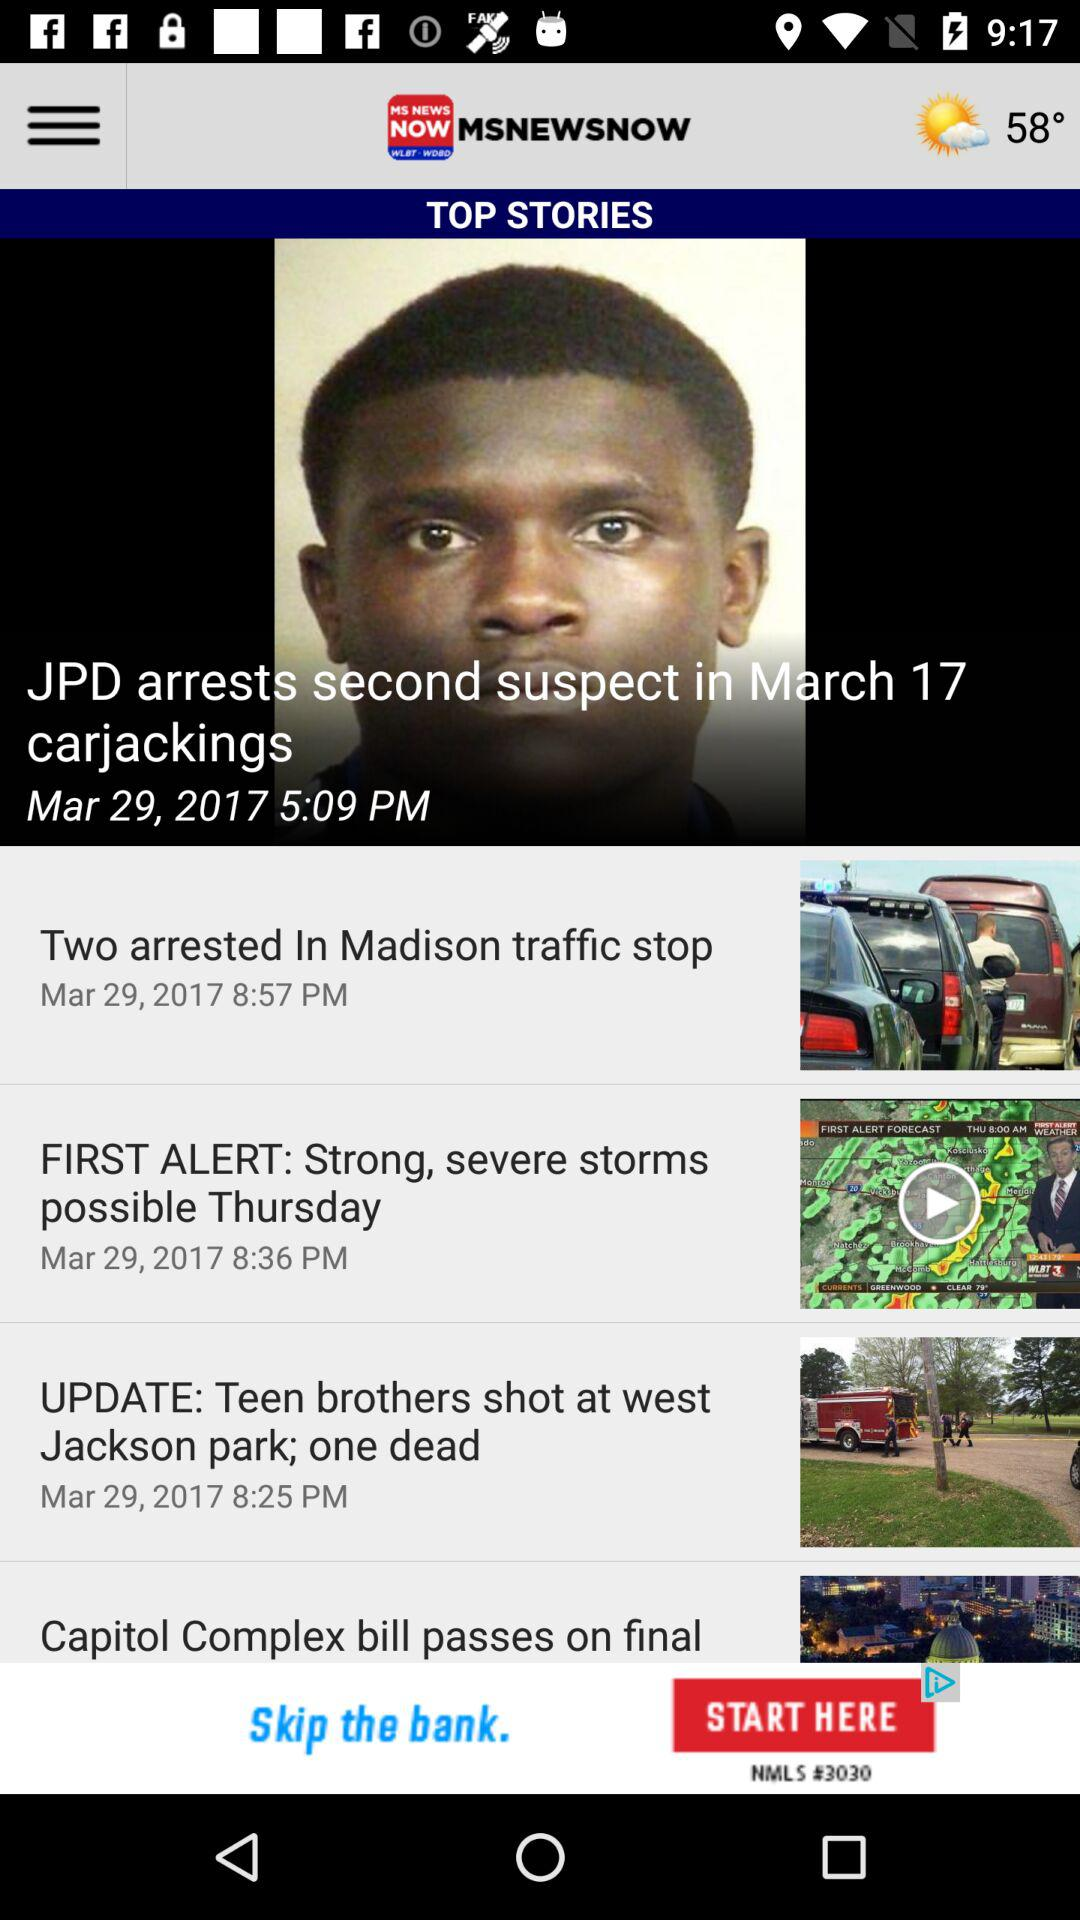On what date did JPD arrest the second suspect? The suspect was arrested on March 17. 